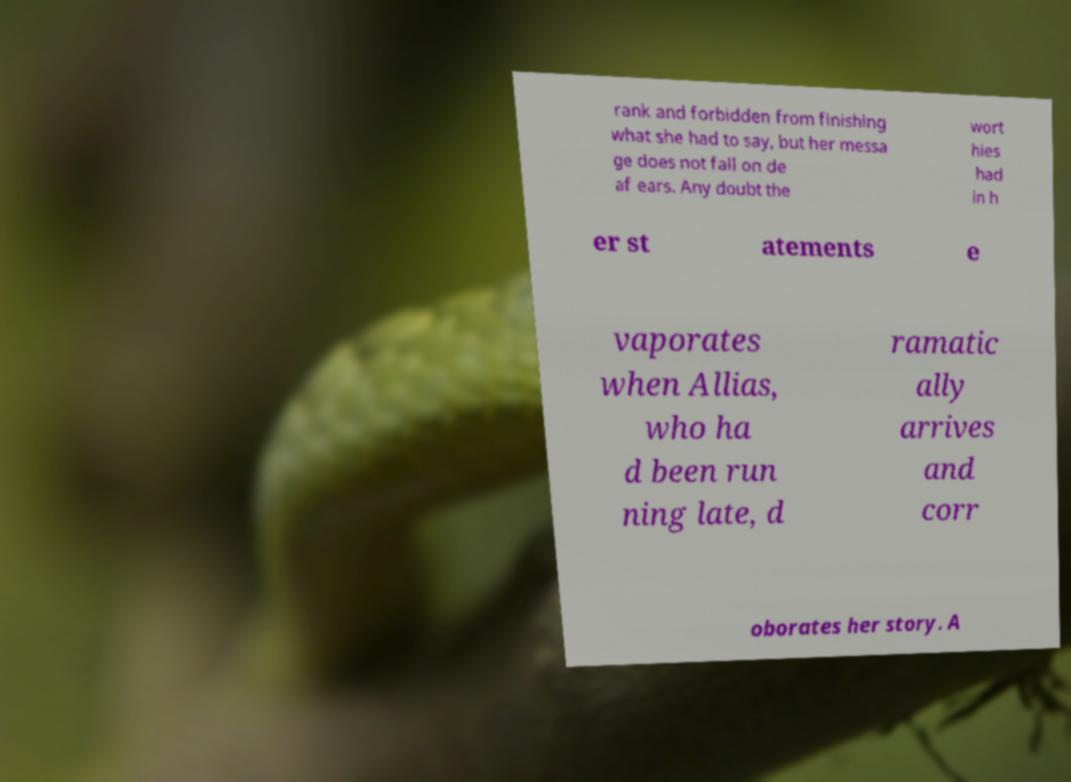For documentation purposes, I need the text within this image transcribed. Could you provide that? rank and forbidden from finishing what she had to say, but her messa ge does not fall on de af ears. Any doubt the wort hies had in h er st atements e vaporates when Allias, who ha d been run ning late, d ramatic ally arrives and corr oborates her story. A 